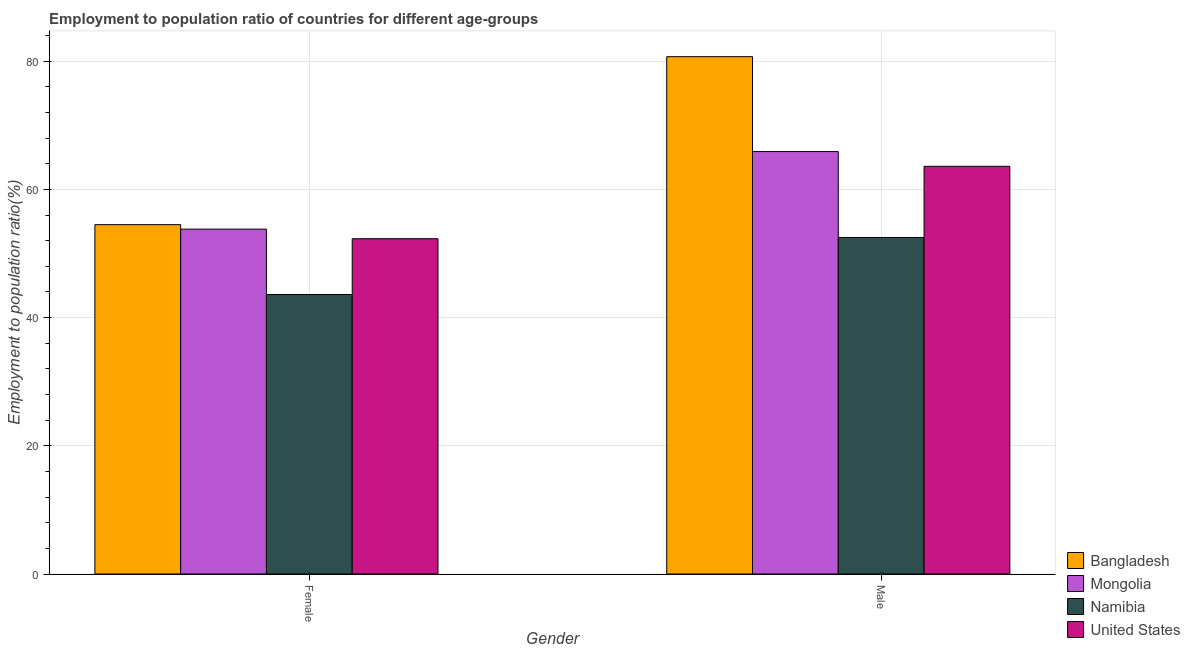How many different coloured bars are there?
Make the answer very short. 4. How many groups of bars are there?
Offer a terse response. 2. Are the number of bars per tick equal to the number of legend labels?
Keep it short and to the point. Yes. How many bars are there on the 2nd tick from the left?
Provide a succinct answer. 4. How many bars are there on the 1st tick from the right?
Make the answer very short. 4. What is the label of the 2nd group of bars from the left?
Your answer should be very brief. Male. What is the employment to population ratio(female) in Bangladesh?
Provide a short and direct response. 54.5. Across all countries, what is the maximum employment to population ratio(female)?
Provide a succinct answer. 54.5. Across all countries, what is the minimum employment to population ratio(female)?
Offer a very short reply. 43.6. In which country was the employment to population ratio(male) maximum?
Offer a very short reply. Bangladesh. In which country was the employment to population ratio(male) minimum?
Your answer should be compact. Namibia. What is the total employment to population ratio(female) in the graph?
Your response must be concise. 204.2. What is the difference between the employment to population ratio(female) in Namibia and the employment to population ratio(male) in Mongolia?
Your answer should be very brief. -22.3. What is the average employment to population ratio(female) per country?
Your answer should be very brief. 51.05. What is the difference between the employment to population ratio(female) and employment to population ratio(male) in Namibia?
Offer a terse response. -8.9. What is the ratio of the employment to population ratio(male) in Bangladesh to that in United States?
Offer a very short reply. 1.27. In how many countries, is the employment to population ratio(male) greater than the average employment to population ratio(male) taken over all countries?
Provide a succinct answer. 2. What does the 2nd bar from the left in Male represents?
Offer a terse response. Mongolia. What does the 1st bar from the right in Female represents?
Ensure brevity in your answer.  United States. How many bars are there?
Offer a very short reply. 8. How many countries are there in the graph?
Provide a succinct answer. 4. Are the values on the major ticks of Y-axis written in scientific E-notation?
Make the answer very short. No. Does the graph contain grids?
Provide a succinct answer. Yes. How many legend labels are there?
Offer a very short reply. 4. What is the title of the graph?
Give a very brief answer. Employment to population ratio of countries for different age-groups. What is the label or title of the X-axis?
Provide a succinct answer. Gender. What is the Employment to population ratio(%) in Bangladesh in Female?
Provide a succinct answer. 54.5. What is the Employment to population ratio(%) of Mongolia in Female?
Your answer should be very brief. 53.8. What is the Employment to population ratio(%) of Namibia in Female?
Your answer should be compact. 43.6. What is the Employment to population ratio(%) of United States in Female?
Your answer should be very brief. 52.3. What is the Employment to population ratio(%) of Bangladesh in Male?
Offer a terse response. 80.7. What is the Employment to population ratio(%) of Mongolia in Male?
Your answer should be very brief. 65.9. What is the Employment to population ratio(%) of Namibia in Male?
Provide a succinct answer. 52.5. What is the Employment to population ratio(%) of United States in Male?
Make the answer very short. 63.6. Across all Gender, what is the maximum Employment to population ratio(%) of Bangladesh?
Ensure brevity in your answer.  80.7. Across all Gender, what is the maximum Employment to population ratio(%) in Mongolia?
Your answer should be very brief. 65.9. Across all Gender, what is the maximum Employment to population ratio(%) in Namibia?
Give a very brief answer. 52.5. Across all Gender, what is the maximum Employment to population ratio(%) in United States?
Your response must be concise. 63.6. Across all Gender, what is the minimum Employment to population ratio(%) in Bangladesh?
Give a very brief answer. 54.5. Across all Gender, what is the minimum Employment to population ratio(%) of Mongolia?
Offer a very short reply. 53.8. Across all Gender, what is the minimum Employment to population ratio(%) of Namibia?
Make the answer very short. 43.6. Across all Gender, what is the minimum Employment to population ratio(%) of United States?
Make the answer very short. 52.3. What is the total Employment to population ratio(%) in Bangladesh in the graph?
Make the answer very short. 135.2. What is the total Employment to population ratio(%) in Mongolia in the graph?
Make the answer very short. 119.7. What is the total Employment to population ratio(%) of Namibia in the graph?
Make the answer very short. 96.1. What is the total Employment to population ratio(%) of United States in the graph?
Provide a short and direct response. 115.9. What is the difference between the Employment to population ratio(%) of Bangladesh in Female and that in Male?
Make the answer very short. -26.2. What is the difference between the Employment to population ratio(%) in Namibia in Female and that in Male?
Your response must be concise. -8.9. What is the difference between the Employment to population ratio(%) of Bangladesh in Female and the Employment to population ratio(%) of Mongolia in Male?
Offer a terse response. -11.4. What is the difference between the Employment to population ratio(%) in Bangladesh in Female and the Employment to population ratio(%) in Namibia in Male?
Provide a short and direct response. 2. What is the difference between the Employment to population ratio(%) of Bangladesh in Female and the Employment to population ratio(%) of United States in Male?
Offer a terse response. -9.1. What is the difference between the Employment to population ratio(%) of Namibia in Female and the Employment to population ratio(%) of United States in Male?
Offer a very short reply. -20. What is the average Employment to population ratio(%) in Bangladesh per Gender?
Your answer should be compact. 67.6. What is the average Employment to population ratio(%) of Mongolia per Gender?
Make the answer very short. 59.85. What is the average Employment to population ratio(%) in Namibia per Gender?
Offer a terse response. 48.05. What is the average Employment to population ratio(%) in United States per Gender?
Make the answer very short. 57.95. What is the difference between the Employment to population ratio(%) of Namibia and Employment to population ratio(%) of United States in Female?
Offer a terse response. -8.7. What is the difference between the Employment to population ratio(%) of Bangladesh and Employment to population ratio(%) of Mongolia in Male?
Keep it short and to the point. 14.8. What is the difference between the Employment to population ratio(%) in Bangladesh and Employment to population ratio(%) in Namibia in Male?
Provide a short and direct response. 28.2. What is the difference between the Employment to population ratio(%) of Bangladesh and Employment to population ratio(%) of United States in Male?
Make the answer very short. 17.1. What is the difference between the Employment to population ratio(%) in Mongolia and Employment to population ratio(%) in Namibia in Male?
Make the answer very short. 13.4. What is the difference between the Employment to population ratio(%) of Mongolia and Employment to population ratio(%) of United States in Male?
Your response must be concise. 2.3. What is the ratio of the Employment to population ratio(%) in Bangladesh in Female to that in Male?
Make the answer very short. 0.68. What is the ratio of the Employment to population ratio(%) in Mongolia in Female to that in Male?
Keep it short and to the point. 0.82. What is the ratio of the Employment to population ratio(%) in Namibia in Female to that in Male?
Your answer should be compact. 0.83. What is the ratio of the Employment to population ratio(%) of United States in Female to that in Male?
Your answer should be compact. 0.82. What is the difference between the highest and the second highest Employment to population ratio(%) in Bangladesh?
Provide a succinct answer. 26.2. What is the difference between the highest and the second highest Employment to population ratio(%) in Namibia?
Provide a succinct answer. 8.9. What is the difference between the highest and the second highest Employment to population ratio(%) of United States?
Give a very brief answer. 11.3. What is the difference between the highest and the lowest Employment to population ratio(%) of Bangladesh?
Provide a succinct answer. 26.2. What is the difference between the highest and the lowest Employment to population ratio(%) of Namibia?
Keep it short and to the point. 8.9. What is the difference between the highest and the lowest Employment to population ratio(%) in United States?
Keep it short and to the point. 11.3. 